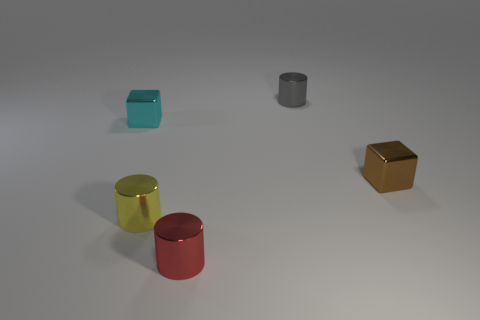Are there an equal number of cylinders to the right of the gray cylinder and small cyan blocks that are to the left of the cyan thing?
Give a very brief answer. Yes. There is a cube to the left of the brown object; is its size the same as the metal cube right of the red shiny thing?
Ensure brevity in your answer.  Yes. Are there more cyan things on the right side of the tiny gray metal cylinder than small green blocks?
Provide a short and direct response. No. Does the yellow thing have the same shape as the red thing?
Keep it short and to the point. Yes. What number of small yellow objects are the same material as the gray object?
Provide a short and direct response. 1. Does the red metal object have the same size as the yellow metallic object?
Ensure brevity in your answer.  Yes. There is a yellow shiny object in front of the cube in front of the thing that is on the left side of the small yellow cylinder; what is its shape?
Your answer should be compact. Cylinder. What is the color of the other object that is the same shape as the brown object?
Your response must be concise. Cyan. How many brown metal things are on the right side of the tiny cube that is in front of the small object on the left side of the small yellow cylinder?
Offer a very short reply. 0. How many tiny things are either red metallic cylinders or cylinders?
Make the answer very short. 3. 